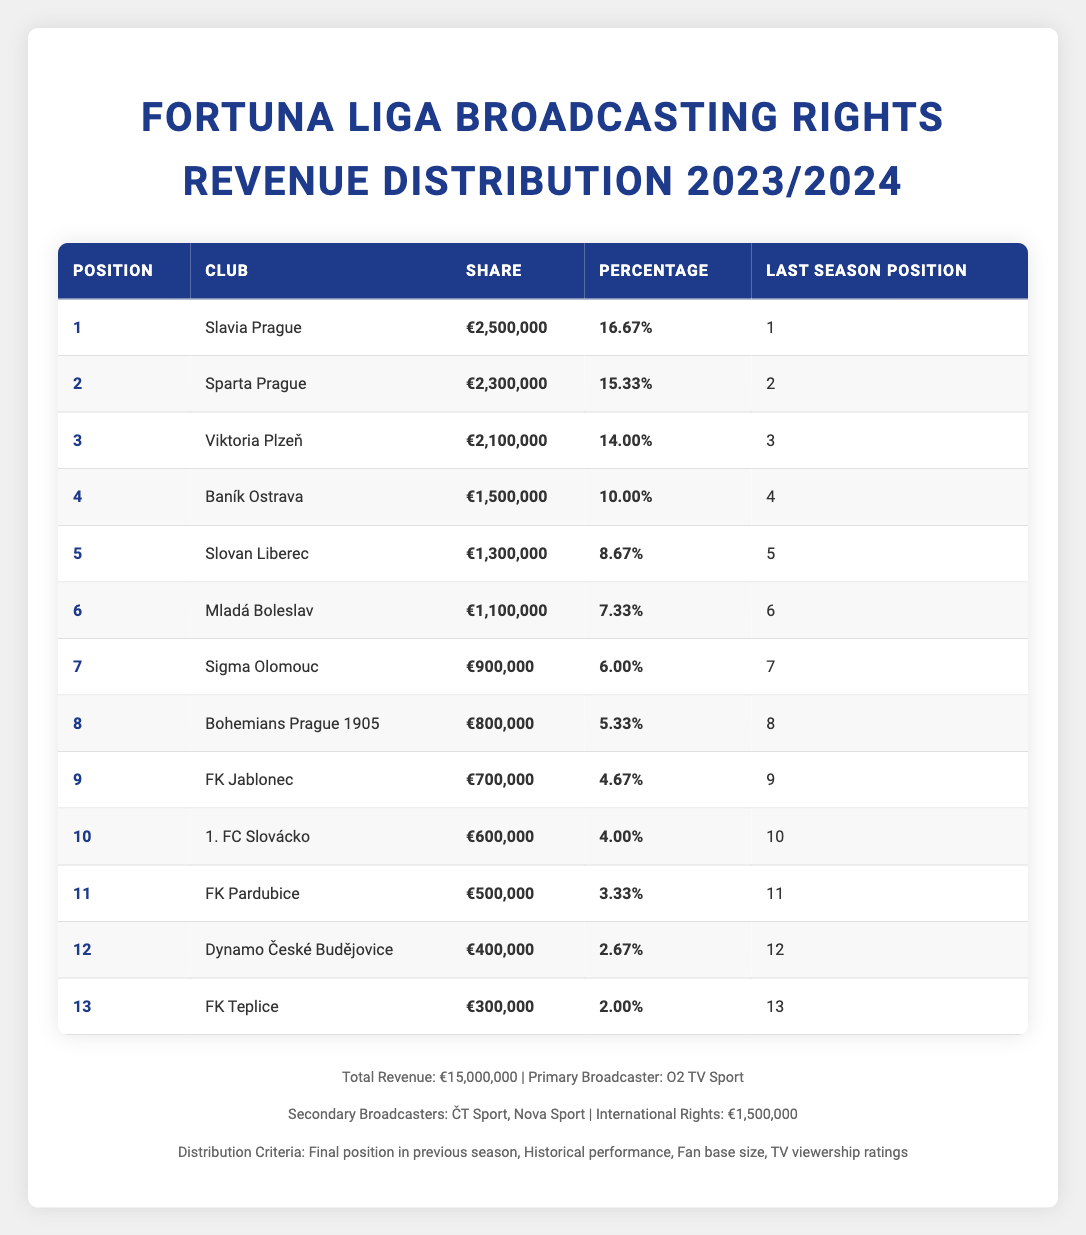What is the total broadcasting rights revenue for the 2023/2024 season? The total revenue listed in the table is explicitly stated as €15,000,000.
Answer: €15,000,000 Which club received the highest share of broadcasting rights revenue? From the table, Slavia Prague is shown to have the highest share of €2,500,000.
Answer: Slavia Prague What percentage of the total revenue does 1. FC Slovácko represent? 1. FC Slovácko's share of €600,000 can be calculated as (600,000 / 15,000,000) * 100, which equals 4%.
Answer: 4% Did any club receive more than €2,200,000 in broadcasting rights revenue? The only clubs that received more than €2,200,000 are Slavia Prague (€2,500,000) and Sparta Prague (€2,300,000), confirming that there are clubs above that amount.
Answer: Yes What is the difference in revenue share between the club ranked 4th and the club ranked 5th? Baník Ostrava, in 4th place, has €1,500,000, and Slovan Liberec, in 5th, has €1,300,000. The difference is €1,500,000 - €1,300,000 = €200,000.
Answer: €200,000 How many clubs received less than €1,000,000 in broadcasting rights revenue? The clubs below €1,000,000 are FK Pardubice (€500,000), Dynamo České Budějovice (€400,000), and FK Teplice (€300,000), totaling three clubs.
Answer: 3 What is the average share for clubs ranked from 11th to 13th? The shares for these clubs are FK Pardubice (€500,000), Dynamo České Budějovice (€400,000), and FK Teplice (€300,000). The average is (500,000 + 400,000 + 300,000) / 3 = €400,000.
Answer: €400,000 Did any club rank in the top 5 last season but receive less than €1,300,000 this season? Slovan Liberec was ranked 5th last season and this season received €1,300,000, while all top 4 ranks this season have above €1,300,000. Therefore, no other club can be considered lower in revenue share while being in the top 5 last season.
Answer: No Which distribution criteria emphasize the importance of historical performance? The criteria listed are Final position in the previous season, Historical performance, Fan base size, and TV viewership ratings. Of these, "Historical performance" directly emphasizes that aspect.
Answer: Historical performance 